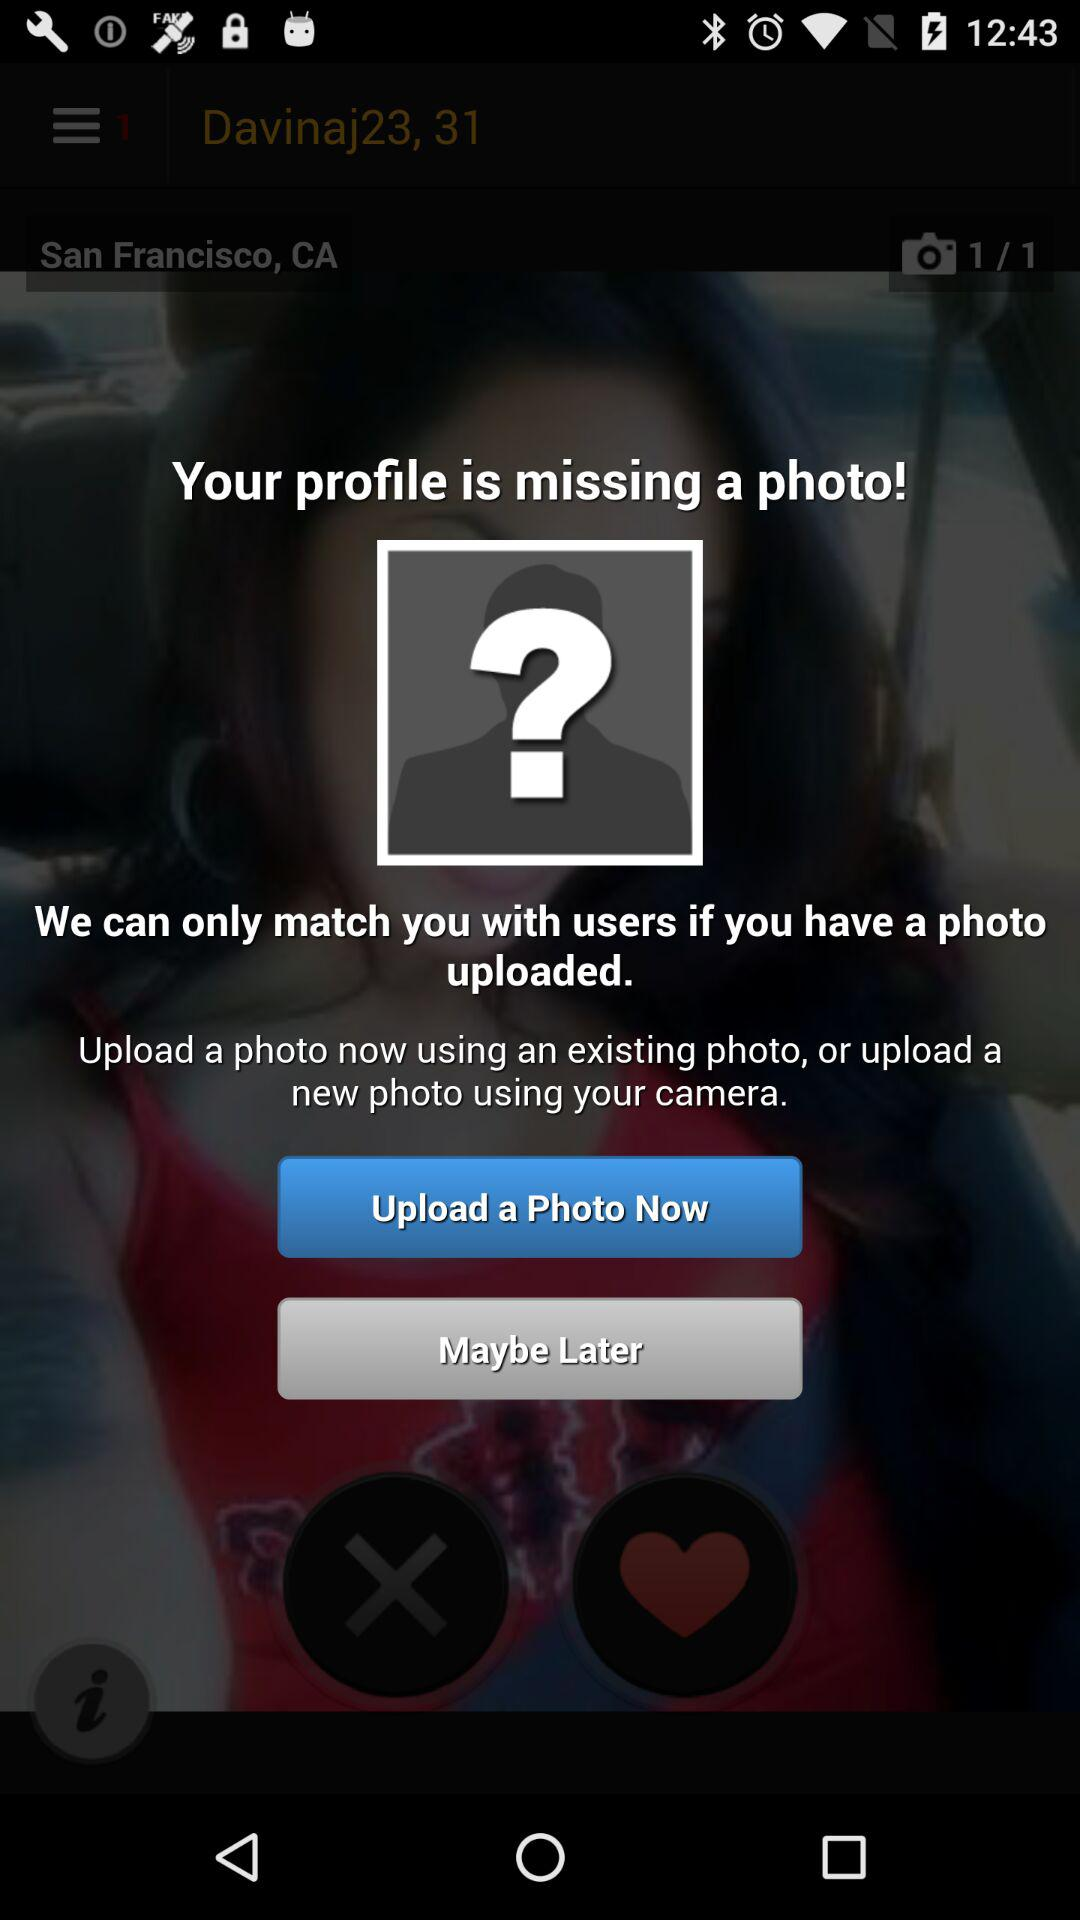How many photos are required to match with users?
Answer the question using a single word or phrase. 1 